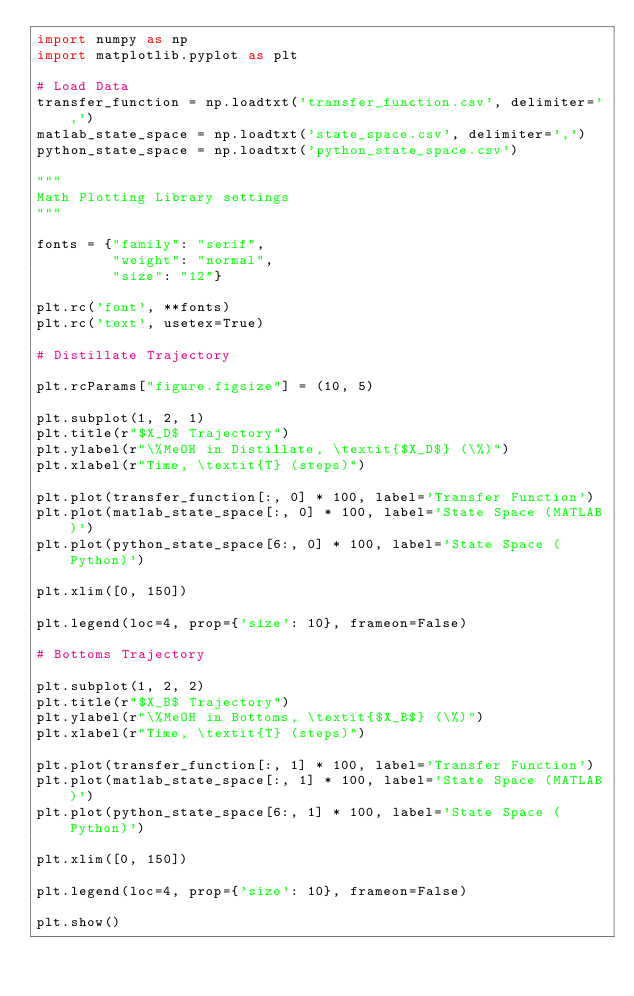Convert code to text. <code><loc_0><loc_0><loc_500><loc_500><_Python_>import numpy as np
import matplotlib.pyplot as plt

# Load Data
transfer_function = np.loadtxt('transfer_function.csv', delimiter=',')
matlab_state_space = np.loadtxt('state_space.csv', delimiter=',')
python_state_space = np.loadtxt('python_state_space.csv')

"""
Math Plotting Library settings
"""

fonts = {"family": "serif",
         "weight": "normal",
         "size": "12"}

plt.rc('font', **fonts)
plt.rc('text', usetex=True)

# Distillate Trajectory

plt.rcParams["figure.figsize"] = (10, 5)

plt.subplot(1, 2, 1)
plt.title(r"$X_D$ Trajectory")
plt.ylabel(r"\%MeOH in Distillate, \textit{$X_D$} (\%)")
plt.xlabel(r"Time, \textit{T} (steps)")

plt.plot(transfer_function[:, 0] * 100, label='Transfer Function')
plt.plot(matlab_state_space[:, 0] * 100, label='State Space (MATLAB)')
plt.plot(python_state_space[6:, 0] * 100, label='State Space (Python)')

plt.xlim([0, 150])

plt.legend(loc=4, prop={'size': 10}, frameon=False)

# Bottoms Trajectory

plt.subplot(1, 2, 2)
plt.title(r"$X_B$ Trajectory")
plt.ylabel(r"\%MeOH in Bottoms, \textit{$X_B$} (\%)")
plt.xlabel(r"Time, \textit{T} (steps)")

plt.plot(transfer_function[:, 1] * 100, label='Transfer Function')
plt.plot(matlab_state_space[:, 1] * 100, label='State Space (MATLAB)')
plt.plot(python_state_space[6:, 1] * 100, label='State Space (Python)')

plt.xlim([0, 150])

plt.legend(loc=4, prop={'size': 10}, frameon=False)

plt.show()
</code> 